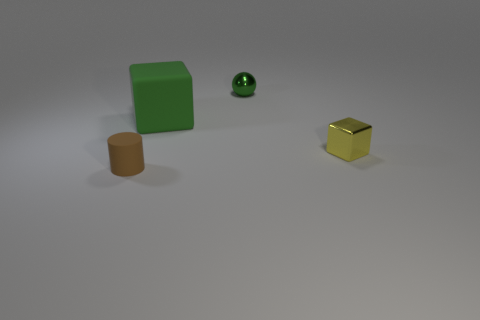Add 3 large rubber things. How many objects exist? 7 Subtract all cylinders. How many objects are left? 3 Subtract all green matte things. Subtract all purple rubber cubes. How many objects are left? 3 Add 2 large matte things. How many large matte things are left? 3 Add 3 small objects. How many small objects exist? 6 Subtract 0 blue cylinders. How many objects are left? 4 